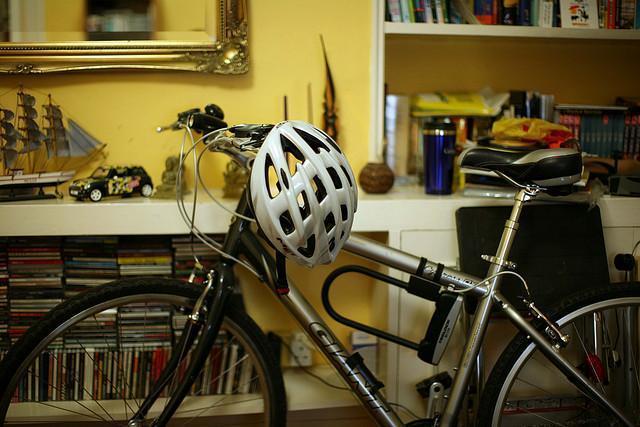Verify the accuracy of this image caption: "The bicycle is at the right side of the boat.".
Answer yes or no. Yes. 